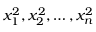<formula> <loc_0><loc_0><loc_500><loc_500>x _ { 1 } ^ { 2 } , x _ { 2 } ^ { 2 } , \dots , x _ { n } ^ { 2 }</formula> 